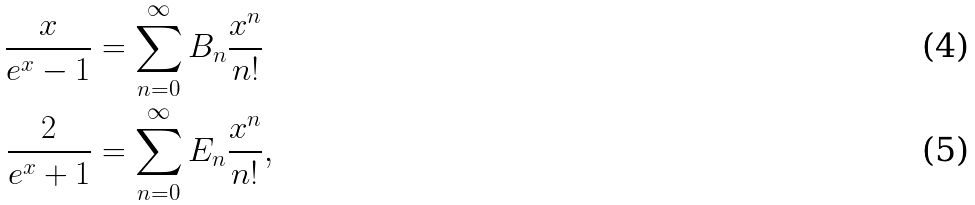<formula> <loc_0><loc_0><loc_500><loc_500>\frac { x } { e ^ { x } - 1 } & = \sum _ { n = 0 } ^ { \infty } B _ { n } \frac { x ^ { n } } { n ! } \\ \frac { 2 } { e ^ { x } + 1 } & = \sum _ { n = 0 } ^ { \infty } E _ { n } \frac { x ^ { n } } { n ! } ,</formula> 